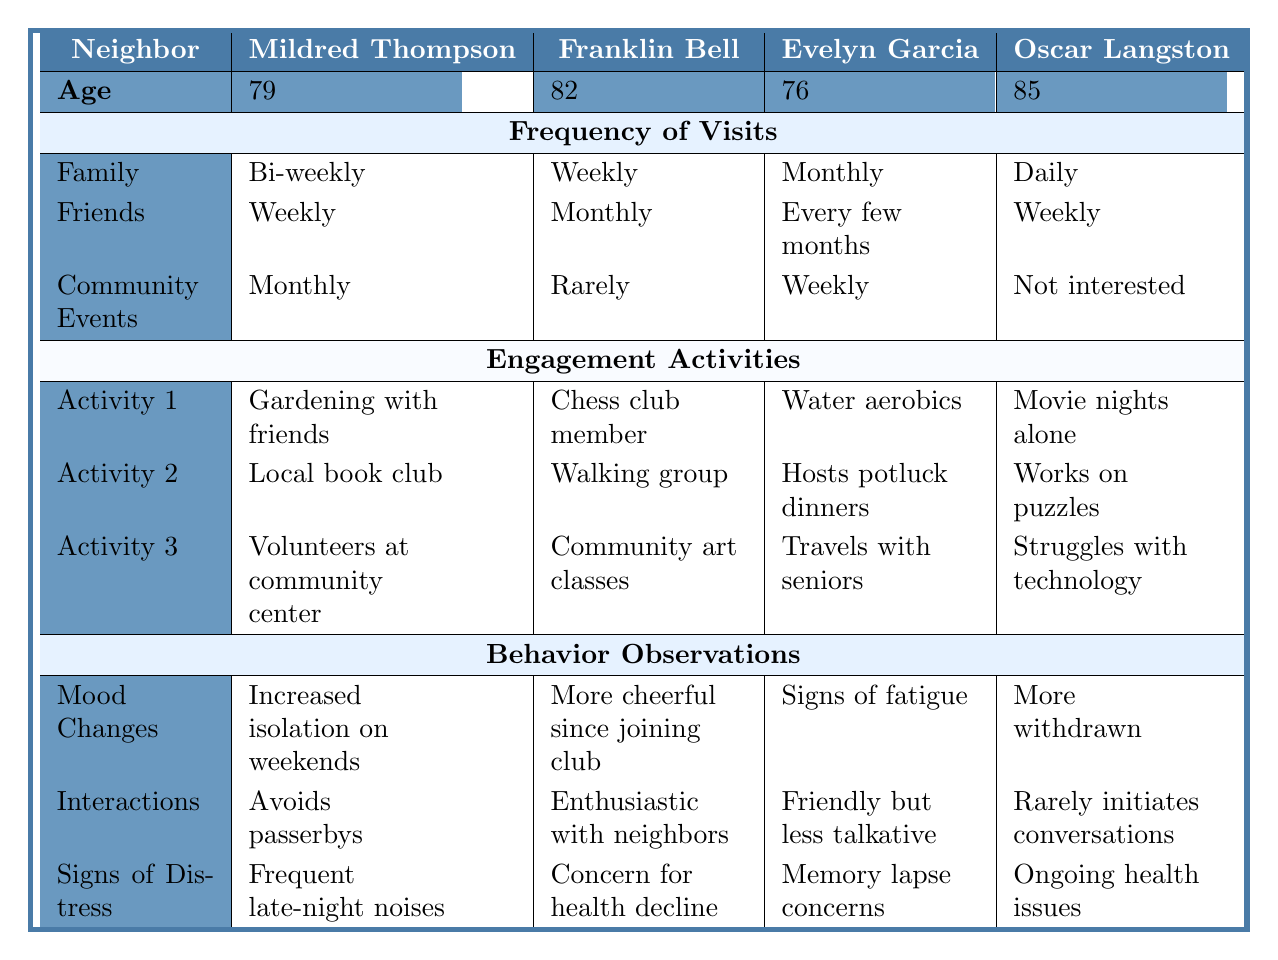What is the age of Evelyn Garcia? The table lists Evelyn Garcia's age under the "Age" section, which shows 76.
Answer: 76 How often does Oscar Langston have family visits? The frequency of family visits for Oscar Langston is specified as "Daily" in the table.
Answer: Daily Which neighbor participates in a book club? The table shows that Mildred Thompson participates in a local book club under the "Engagement Activities" section.
Answer: Mildred Thompson What is the most frequent family visit frequency among the neighbors? In the table, every neighbor's family visit frequency is listed: Bi-weekly, Weekly, Monthly, and Daily. Daily is the most frequent.
Answer: Daily Does Franklin Bell regularly participate in community events? The table indicates that Franklin Bell participates in community events "Rarely," which implies he does not participate regularly.
Answer: No Which neighbor shows signs of increased isolation? The "Behavior Observations" section indicates that Mildred Thompson has "Increased isolation on weekends."
Answer: Mildred Thompson What is the frequency of visits from friends for Evelyn Garcia? The table specifies that Evelyn Garcia's frequency of visits from friends is "Every few months."
Answer: Every few months Between Mildred Thompson and Evelyn Garcia, who has more social interaction with friends? Mildred Thompson has weekly visits from friends, while Evelyn Garcia's visits are every few months, indicating that Mildred engages more socially.
Answer: Mildred Thompson What are Oscar Langston's engagement activities? The table lists his activities as "Enjoys watching movies alone," "Frequently works on puzzles," and "Struggles to keep up with technology."
Answer: Movie nights alone, puzzles, struggles with technology How many neighbors are noted for displaying signs of distress due to health concerns? The table shows that Franklin Bell has concerns about health decline and Oscar Langston has ongoing health issues, so there are two neighbors with health-related distress.
Answer: 2 Is there a neighbor who is a regular member of a social club? Franklin Bell is noted as a "Regular member of local chess club" in the "Engagement Activities" section, confirming he is involved in a social club.
Answer: Yes Who has the least frequent community event participation? From the community event participation shown in the table, Oscar Langston is listed as "Not interested," which is the least frequent.
Answer: Oscar Langston What is the difference in frequency of community event participation between Franklin Bell and Evelyn Garcia? Franklin Bell participates "Rarely" while Evelyn Garcia participates "Weekly." The difference in their frequency levels shows that Evelyn Garcia engages more often.
Answer: Weekly - Rarely Which neighbor experiences fatigue according to the "Behavior Observations"? The behavior observations for Evelyn Garcia indicate her "Exhibits signs of fatigue."
Answer: Evelyn Garcia Which engagement activity is noted for Mildred Thompson? She is observed to "Loves to garden with friends," which is one of her engagement activities.
Answer: Gardening with friends Does the table indicate if any neighbor has ongoing health issues? Yes, Oscar Langston's behavior observations mention "Ongoing health issues."
Answer: Yes How often do friends visit Franklin Bell compared to family? Family visits are "Weekly," and friends visit "Monthly," showing that family visits occur more frequently than friends.
Answer: Weekly vs Monthly 